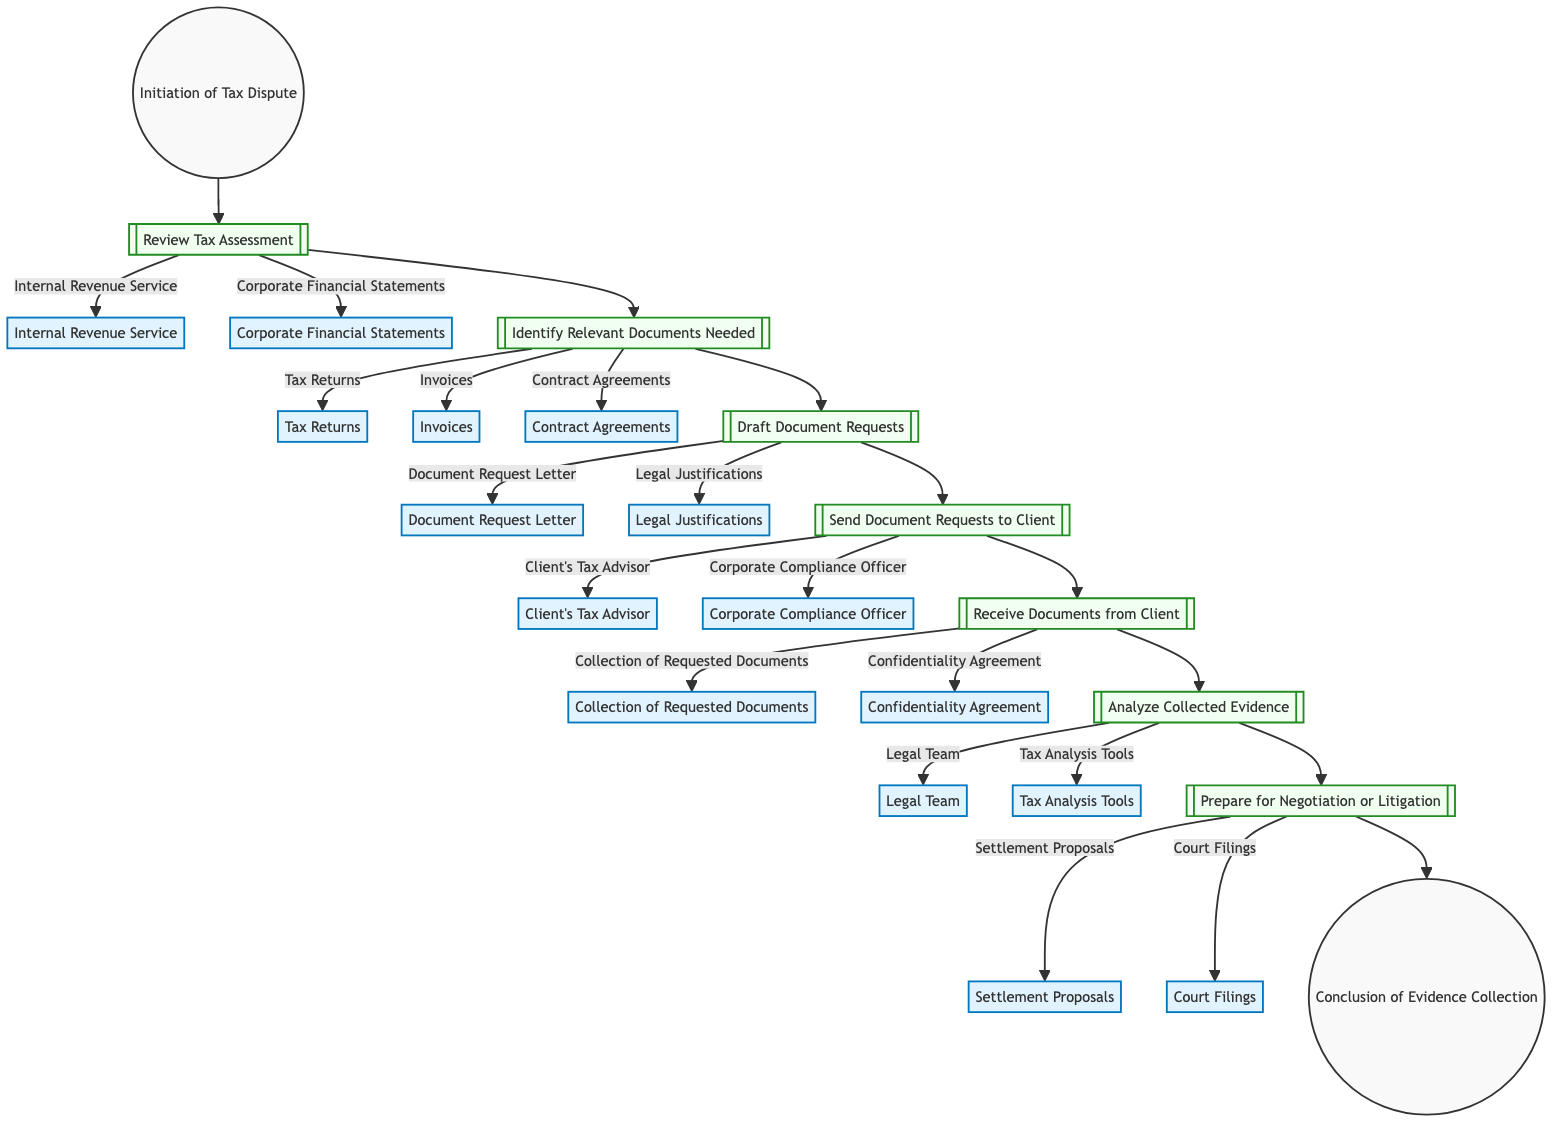What is the first step in the flow of evidence collection? The first step in the flow is labeled as "Initiation of Tax Dispute," indicating that this is where the process begins.
Answer: Initiation of Tax Dispute How many steps are there in the diagram? By counting from the start to the end, there are a total of 7 steps shown in the flowchart, progressing from the initiation to the conclusion of evidence collection.
Answer: 7 Which document is reviewed in Step 1? In Step 1, the diagram specifies that the document reviewed is the "Tax Assessment," which is an essential part of the initial evaluation stage.
Answer: Tax Assessment What entity is involved in Step 4? In Step 4, the entities involved are "Client's Tax Advisor" and "Corporate Compliance Officer," responsible for communication regarding the document requests.
Answer: Client's Tax Advisor, Corporate Compliance Officer What comes after "Analyze Collected Evidence"? Following the analysis stage, the next step in the flow is "Prepare for Negotiation or Litigation," indicating a transition towards possible resolution strategies.
Answer: Prepare for Negotiation or Litigation Which tools are utilized according to Step 6? In Step 6, the tools utilized for the analysis of collected evidence include "Tax Analysis Tools," which aid the legal team in examining the evidence effectively.
Answer: Tax Analysis Tools What is the concluding step in the flowchart? The final step, or the conclusion of the flowchart process, is labeled as "Conclusion of Evidence Collection," marking the end of this specific workflow.
Answer: Conclusion of Evidence Collection What type of agreement is mentioned in Step 5? In Step 5, a "Confidentiality Agreement" is highlighted as an important document that guarantees the privacy of information during the evidence collection phase.
Answer: Confidentiality Agreement Which entities are linked to Step 2? The entities linked to Step 2 are "Tax Returns," "Invoices," and "Contract Agreements," which are identified as relevant documents needed for the dispute.
Answer: Tax Returns, Invoices, Contract Agreements 